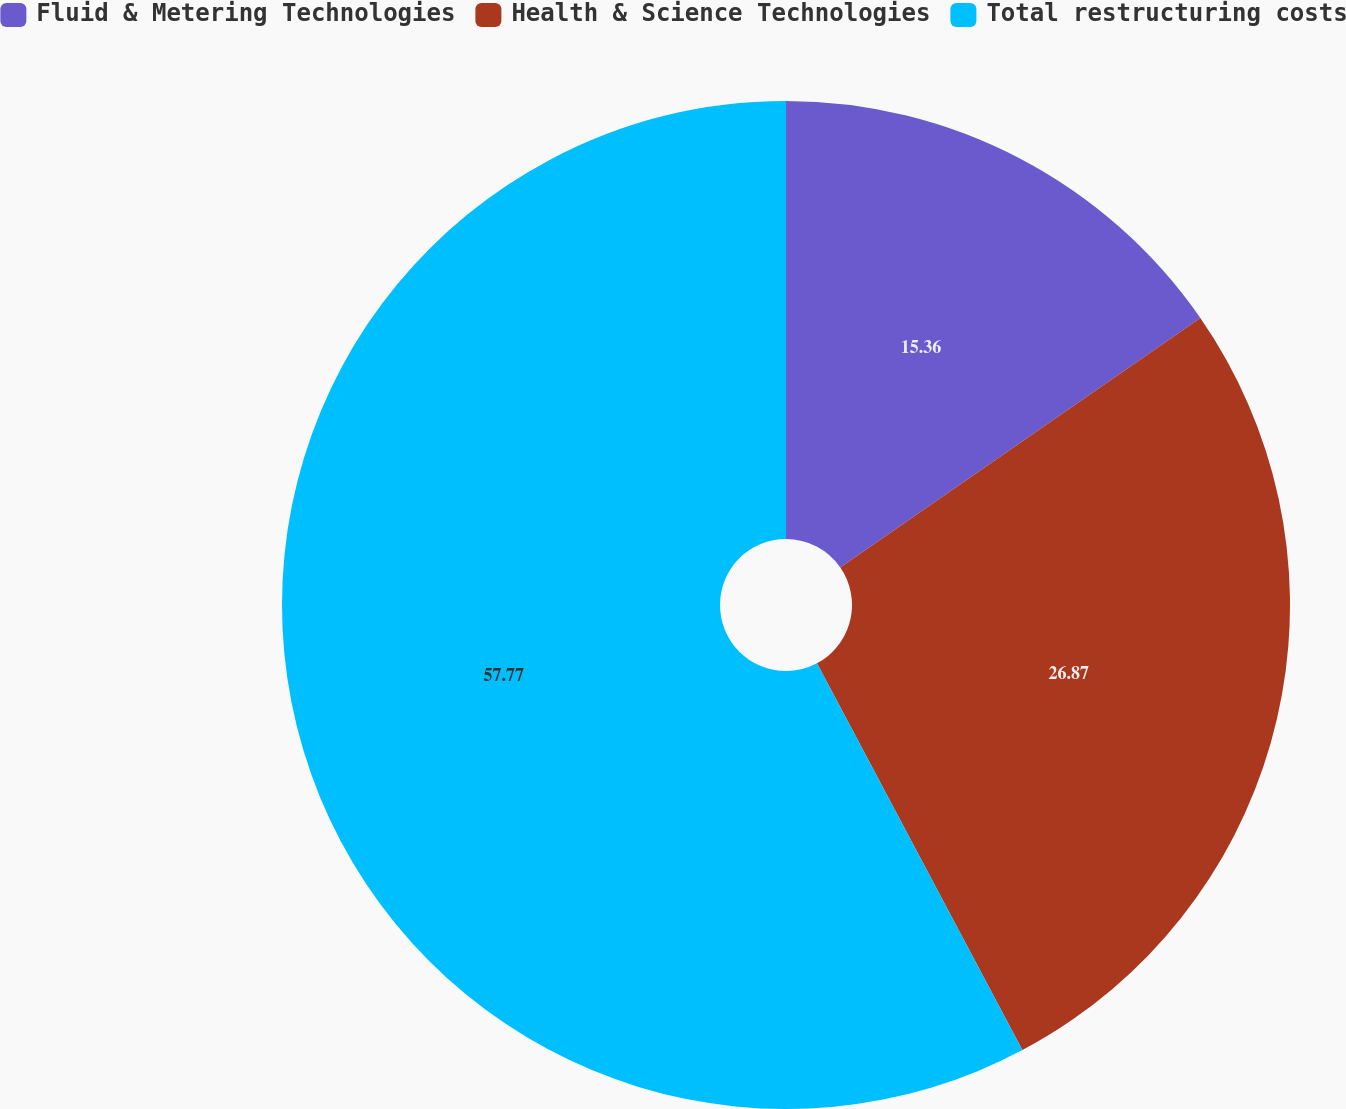Convert chart to OTSL. <chart><loc_0><loc_0><loc_500><loc_500><pie_chart><fcel>Fluid & Metering Technologies<fcel>Health & Science Technologies<fcel>Total restructuring costs<nl><fcel>15.36%<fcel>26.87%<fcel>57.77%<nl></chart> 